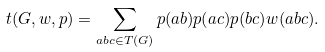Convert formula to latex. <formula><loc_0><loc_0><loc_500><loc_500>t ( G , w , p ) = \sum _ { a b c \in T ( G ) } p ( a b ) p ( a c ) p ( b c ) w ( a b c ) .</formula> 